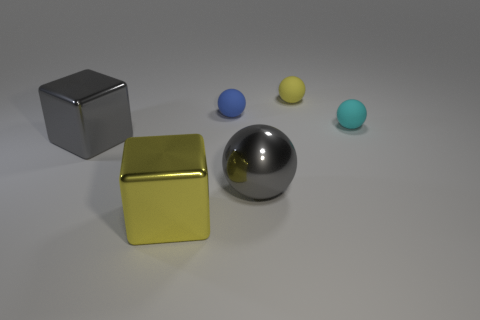Is the number of large objects that are on the right side of the blue rubber ball less than the number of big objects in front of the gray cube?
Offer a terse response. Yes. There is a ball in front of the tiny cyan thing; does it have the same color as the metal block behind the metallic sphere?
Make the answer very short. Yes. There is a tiny sphere that is in front of the yellow ball and on the left side of the cyan thing; what is it made of?
Provide a succinct answer. Rubber. Is there a tiny cyan cylinder?
Make the answer very short. No. There is a gray object that is made of the same material as the gray cube; what is its shape?
Make the answer very short. Sphere. Does the small blue rubber object have the same shape as the yellow thing behind the yellow metallic thing?
Ensure brevity in your answer.  Yes. The cube in front of the ball in front of the cyan matte ball is made of what material?
Keep it short and to the point. Metal. How many other things are the same shape as the yellow shiny thing?
Give a very brief answer. 1. There is a large gray shiny thing that is right of the gray block; is it the same shape as the thing behind the blue matte thing?
Offer a terse response. Yes. What is the small yellow object made of?
Ensure brevity in your answer.  Rubber. 